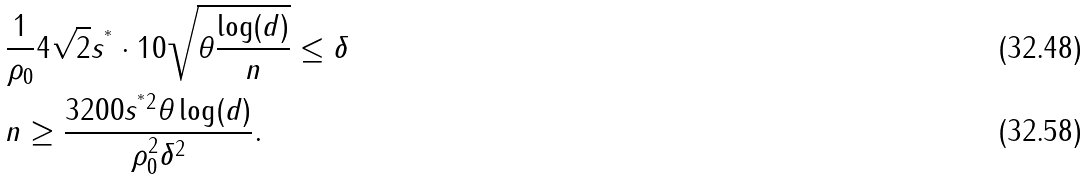<formula> <loc_0><loc_0><loc_500><loc_500>& \frac { 1 } { \rho _ { 0 } } 4 \sqrt { 2 } s ^ { ^ { * } } \cdot 1 0 \sqrt { \theta \frac { \log ( d ) } { n } } \leq \delta \\ & n \geq \frac { 3 2 0 0 s ^ { ^ { * } 2 } \theta \log ( d ) } { \rho _ { 0 } ^ { 2 } \delta ^ { 2 } } .</formula> 